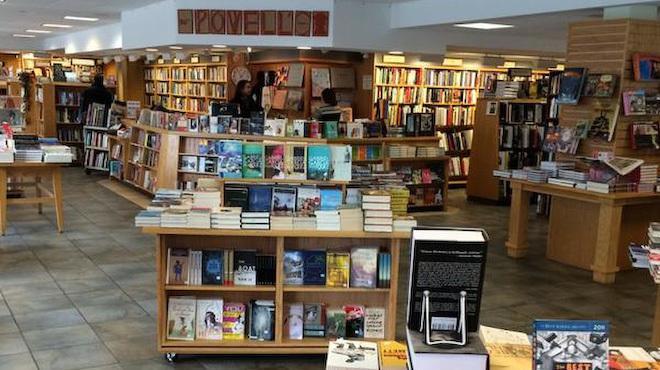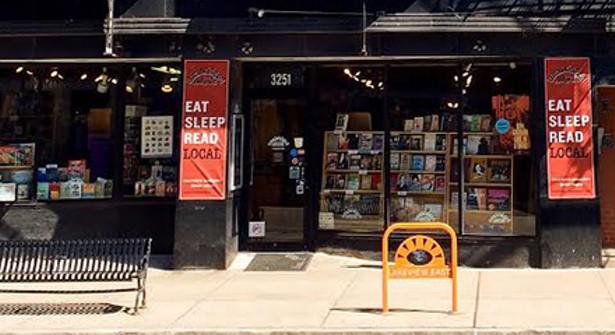The first image is the image on the left, the second image is the image on the right. Considering the images on both sides, is "A yellow sign sits on the sidewalk in the image on the right." valid? Answer yes or no. Yes. The first image is the image on the left, the second image is the image on the right. For the images shown, is this caption "Both pictures show the inside of a bookstore." true? Answer yes or no. No. 